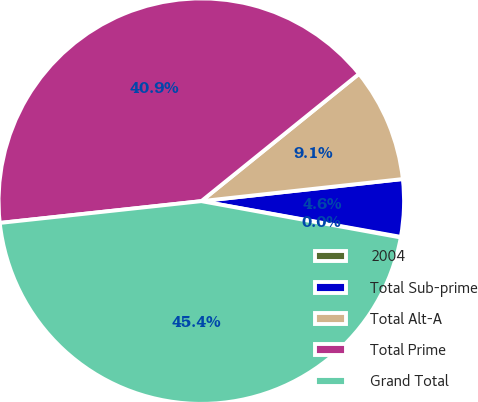<chart> <loc_0><loc_0><loc_500><loc_500><pie_chart><fcel>2004<fcel>Total Sub-prime<fcel>Total Alt-A<fcel>Total Prime<fcel>Grand Total<nl><fcel>0.05%<fcel>4.56%<fcel>9.07%<fcel>40.91%<fcel>45.42%<nl></chart> 